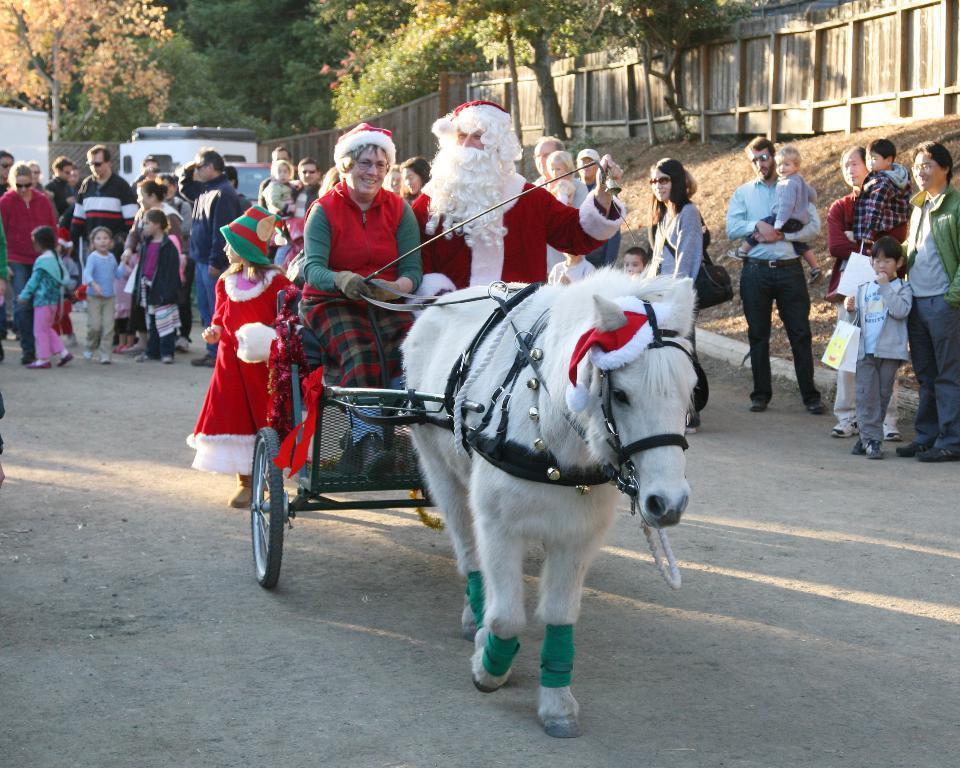How would you summarize this image in a sentence or two? In the center of the image there is a horse carriage. On the carriage, we can see a few people in different costumes. In the background, we can see trees, few people are standing, wooden fence and a few other objects. 